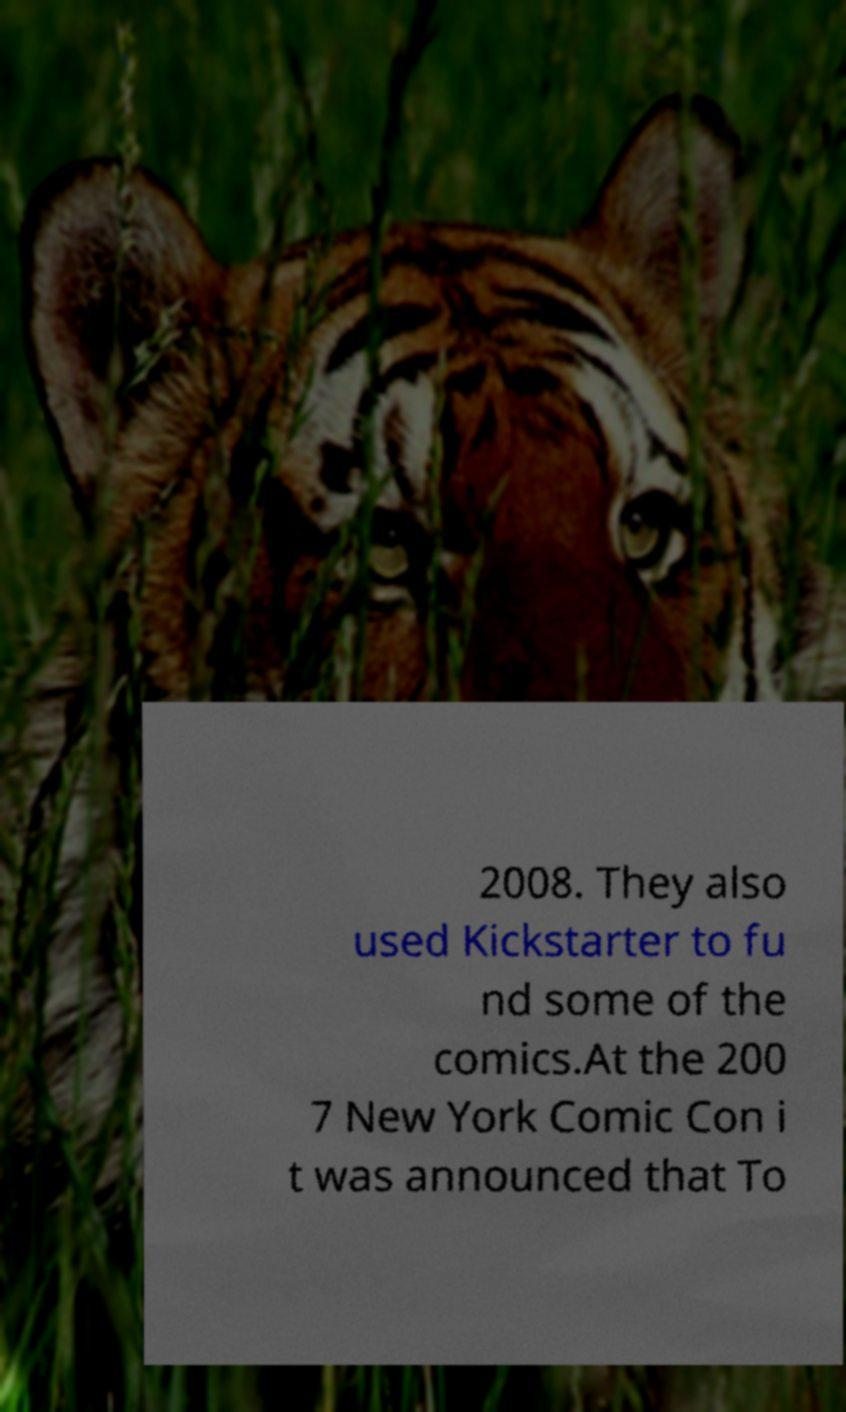What messages or text are displayed in this image? I need them in a readable, typed format. 2008. They also used Kickstarter to fu nd some of the comics.At the 200 7 New York Comic Con i t was announced that To 